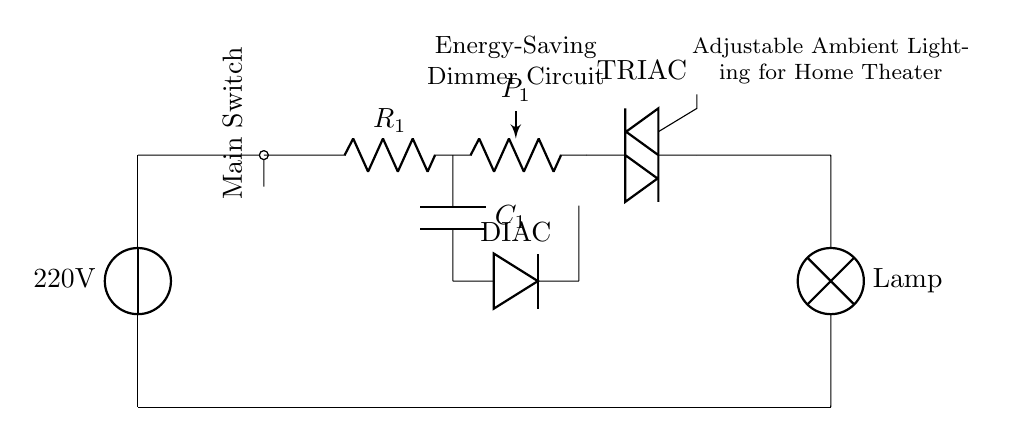What is the voltage of the power source in this circuit? The voltage is labeled as 220 volts in the power source symbol at the top of the schematic.
Answer: 220 volts What component is used for varying light intensity? The component responsible for adjusting the light intensity is the potentiometer, labeled as P1 in the circuit diagram.
Answer: Potentiometer How many main components are there in this dimmer circuit? The main components include the power source, switch, resistor, potentiometer, TRIAC, capacitor, diac, and lamp, totaling to seven key components in the circuit.
Answer: Seven What is the function of the TRIAC in this circuit? The TRIAC acts as a switching device that controls the flow of current to the light source depending on the settings of the potentiometer, effectively dimming the light as necessary.
Answer: Control current flow What is connected directly to the power source in this circuit? The main switch is connected directly to the power source, as shown by the short connection leading from the power source to the switch.
Answer: Main switch What is the role of the capacitor in this energy-saving dimmer circuit? The capacitor stores electrical energy and works in conjunction with the diac to determine when the TRIAC will conduct, thereby influencing the timing and intensity of the light output.
Answer: Energy storage 